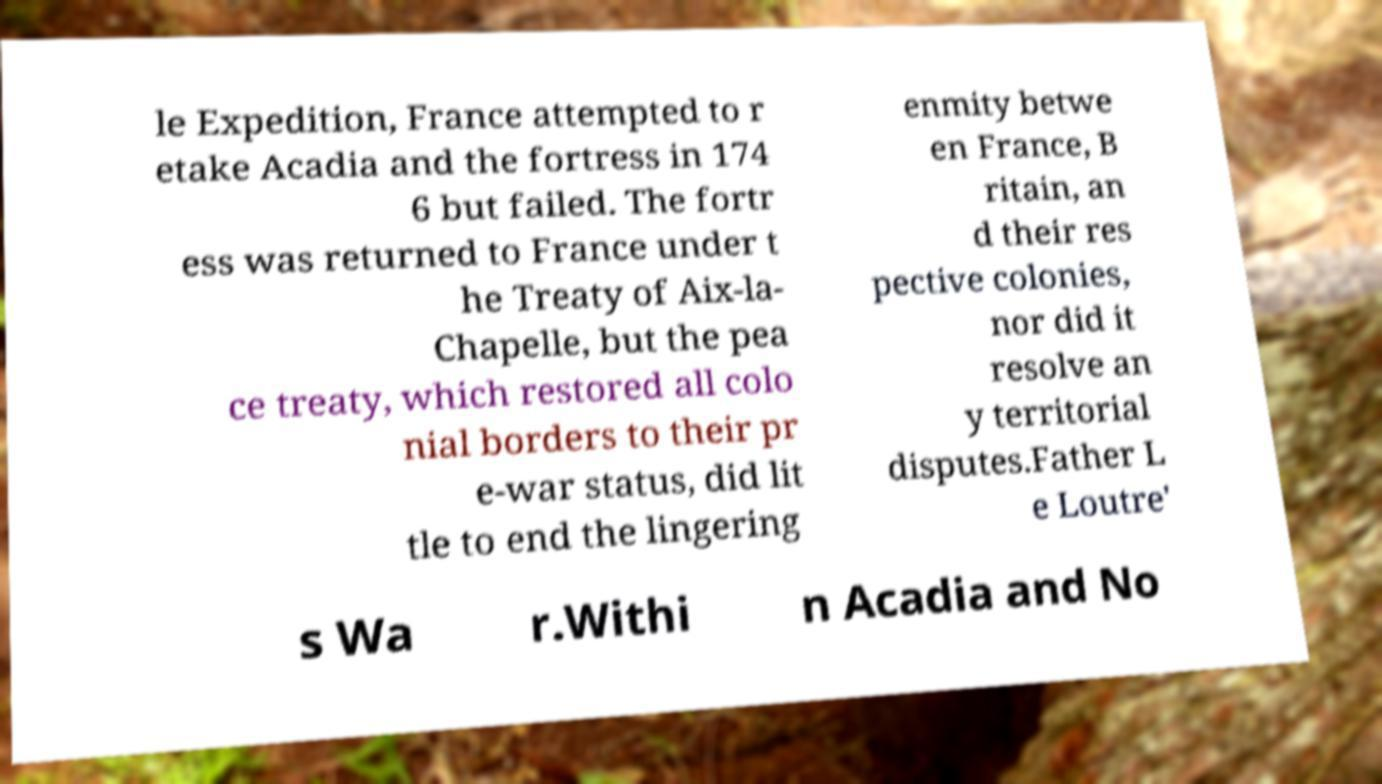For documentation purposes, I need the text within this image transcribed. Could you provide that? le Expedition, France attempted to r etake Acadia and the fortress in 174 6 but failed. The fortr ess was returned to France under t he Treaty of Aix-la- Chapelle, but the pea ce treaty, which restored all colo nial borders to their pr e-war status, did lit tle to end the lingering enmity betwe en France, B ritain, an d their res pective colonies, nor did it resolve an y territorial disputes.Father L e Loutre' s Wa r.Withi n Acadia and No 